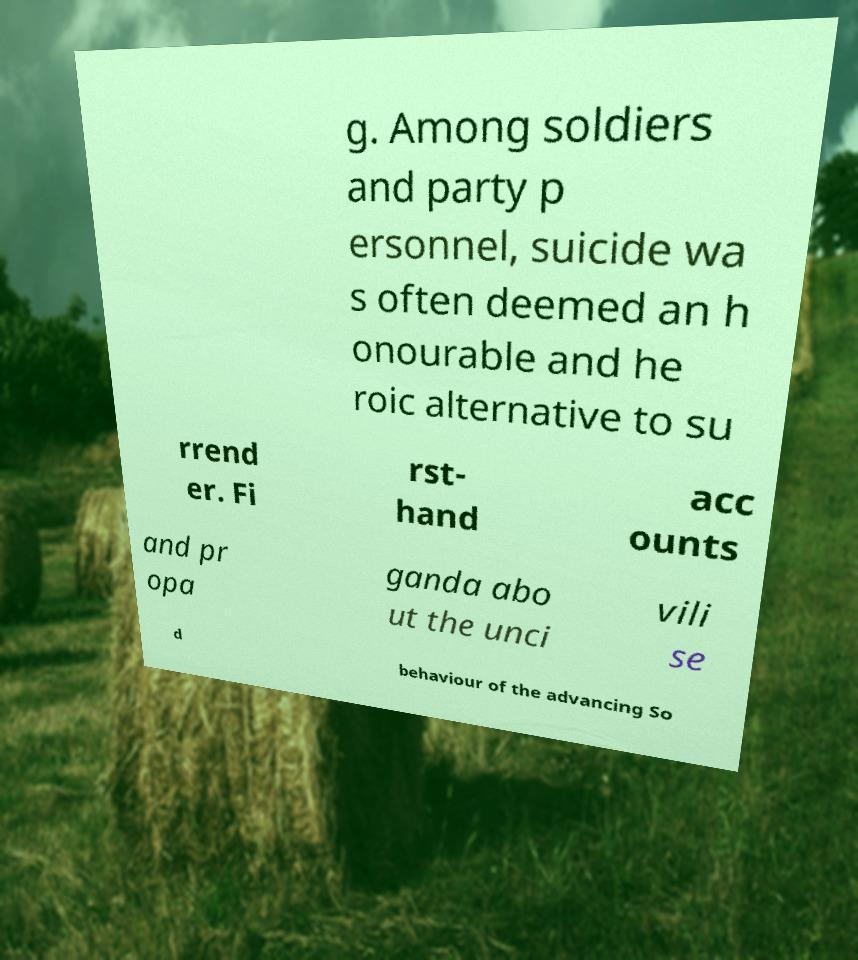What messages or text are displayed in this image? I need them in a readable, typed format. g. Among soldiers and party p ersonnel, suicide wa s often deemed an h onourable and he roic alternative to su rrend er. Fi rst- hand acc ounts and pr opa ganda abo ut the unci vili se d behaviour of the advancing So 